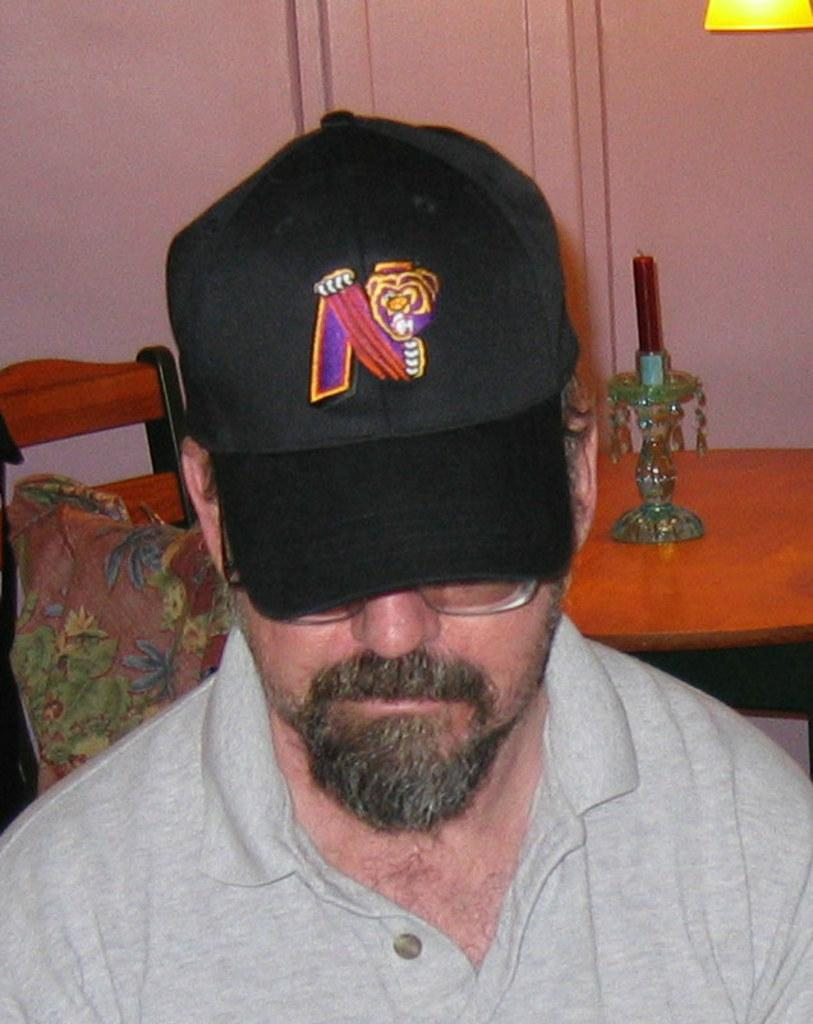What is the main subject of the image? There is a man in the image. What is the man wearing on his upper body? The man is wearing a t-shirt. What is the man wearing on his head? The man is wearing a cap on his head. What furniture can be seen in the image? There is a table and a chair in the image. What can be seen in the background of the image? There is a wall visible in the background. What type of throat medicine is the man holding in the image? There is no throat medicine present in the image; the man is not holding anything. 